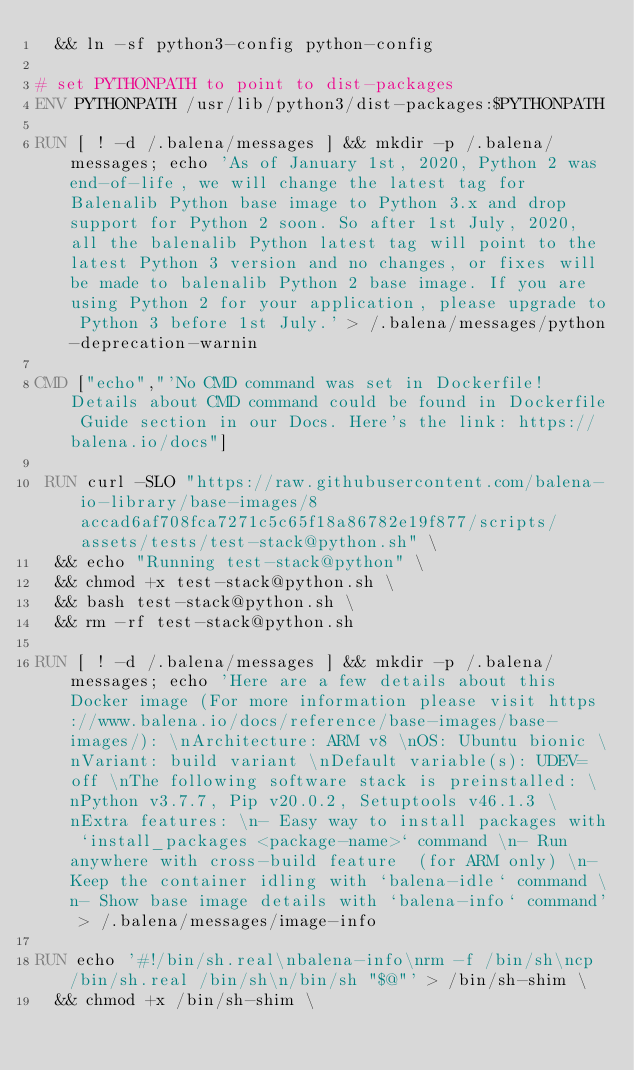<code> <loc_0><loc_0><loc_500><loc_500><_Dockerfile_>	&& ln -sf python3-config python-config

# set PYTHONPATH to point to dist-packages
ENV PYTHONPATH /usr/lib/python3/dist-packages:$PYTHONPATH

RUN [ ! -d /.balena/messages ] && mkdir -p /.balena/messages; echo 'As of January 1st, 2020, Python 2 was end-of-life, we will change the latest tag for Balenalib Python base image to Python 3.x and drop support for Python 2 soon. So after 1st July, 2020, all the balenalib Python latest tag will point to the latest Python 3 version and no changes, or fixes will be made to balenalib Python 2 base image. If you are using Python 2 for your application, please upgrade to Python 3 before 1st July.' > /.balena/messages/python-deprecation-warnin

CMD ["echo","'No CMD command was set in Dockerfile! Details about CMD command could be found in Dockerfile Guide section in our Docs. Here's the link: https://balena.io/docs"]

 RUN curl -SLO "https://raw.githubusercontent.com/balena-io-library/base-images/8accad6af708fca7271c5c65f18a86782e19f877/scripts/assets/tests/test-stack@python.sh" \
  && echo "Running test-stack@python" \
  && chmod +x test-stack@python.sh \
  && bash test-stack@python.sh \
  && rm -rf test-stack@python.sh 

RUN [ ! -d /.balena/messages ] && mkdir -p /.balena/messages; echo 'Here are a few details about this Docker image (For more information please visit https://www.balena.io/docs/reference/base-images/base-images/): \nArchitecture: ARM v8 \nOS: Ubuntu bionic \nVariant: build variant \nDefault variable(s): UDEV=off \nThe following software stack is preinstalled: \nPython v3.7.7, Pip v20.0.2, Setuptools v46.1.3 \nExtra features: \n- Easy way to install packages with `install_packages <package-name>` command \n- Run anywhere with cross-build feature  (for ARM only) \n- Keep the container idling with `balena-idle` command \n- Show base image details with `balena-info` command' > /.balena/messages/image-info

RUN echo '#!/bin/sh.real\nbalena-info\nrm -f /bin/sh\ncp /bin/sh.real /bin/sh\n/bin/sh "$@"' > /bin/sh-shim \
	&& chmod +x /bin/sh-shim \</code> 